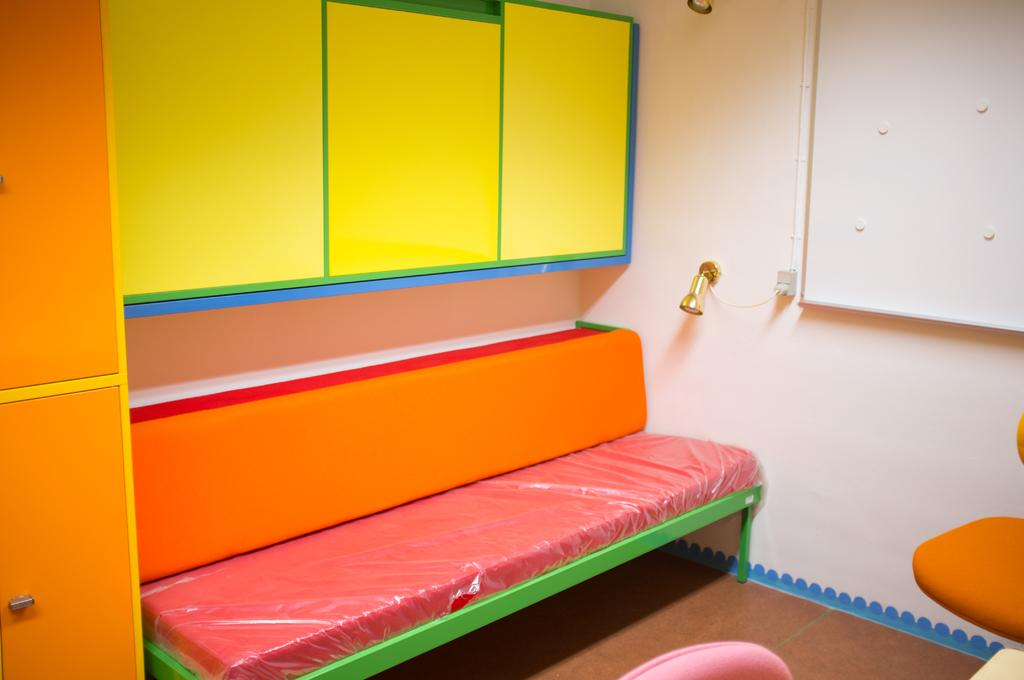What type of furniture is present in the image? There is a sofa and chairs in the image. What other objects can be seen in the image? There are cupboards, a light, a board, and a wall in the image. Can you describe the board in the image? The board is a flat surface that may be used for displaying information or as a writing surface. What is the purpose of the light in the image? The light provides illumination in the room. What nation is depicted on the board in the image? There is no nation depicted on the board in the image; it is a plain board with no visible content. 